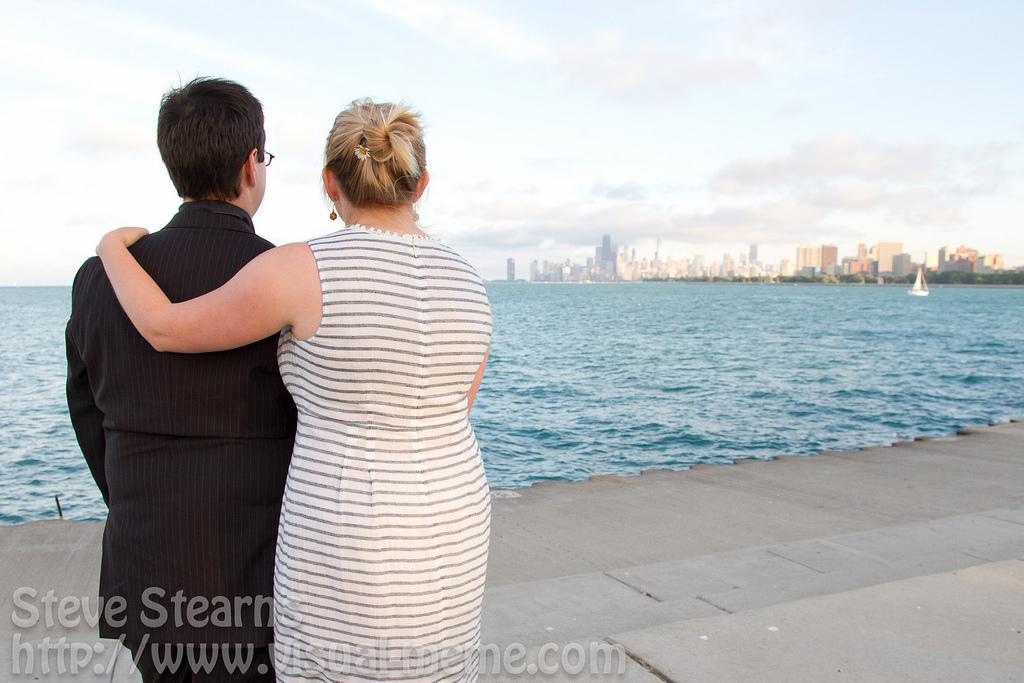Could you give a brief overview of what you see in this image? In this picture we can see a man and woman are looking at the water and on water there is boat and on other side of water we can see buildings and above this we have a sky with clouds and this two persons are standing on a platform. 